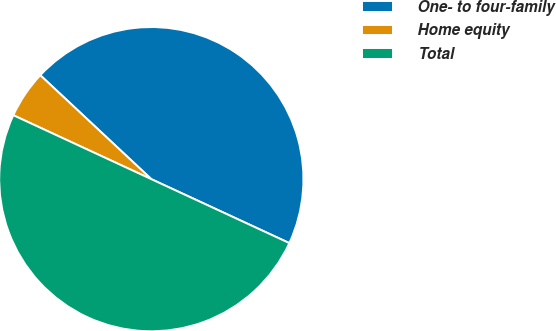<chart> <loc_0><loc_0><loc_500><loc_500><pie_chart><fcel>One- to four-family<fcel>Home equity<fcel>Total<nl><fcel>44.93%<fcel>5.07%<fcel>50.0%<nl></chart> 